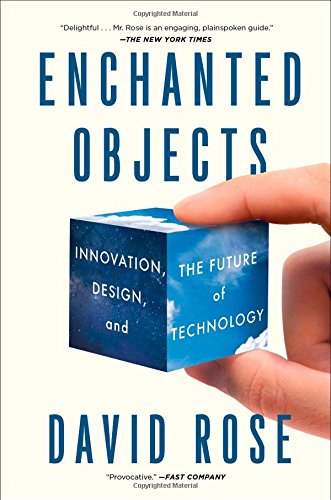Who wrote this book? The book 'Enchanted Objects: Innovation, Design, and the Future of Technology' was authored by David Rose, a visionary in the field of technology and design. 